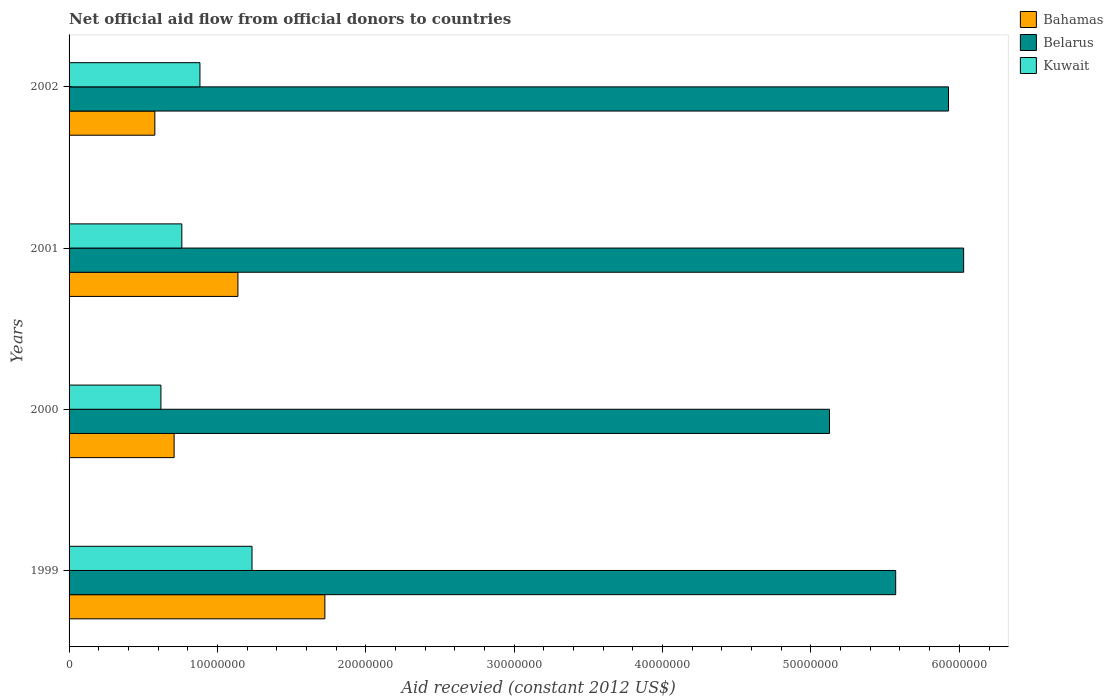Are the number of bars per tick equal to the number of legend labels?
Offer a very short reply. Yes. Are the number of bars on each tick of the Y-axis equal?
Offer a very short reply. Yes. How many bars are there on the 4th tick from the top?
Offer a terse response. 3. How many bars are there on the 3rd tick from the bottom?
Provide a succinct answer. 3. What is the label of the 2nd group of bars from the top?
Ensure brevity in your answer.  2001. What is the total aid received in Kuwait in 2001?
Provide a succinct answer. 7.60e+06. Across all years, what is the maximum total aid received in Bahamas?
Your response must be concise. 1.72e+07. Across all years, what is the minimum total aid received in Kuwait?
Offer a very short reply. 6.19e+06. In which year was the total aid received in Bahamas minimum?
Provide a short and direct response. 2002. What is the total total aid received in Bahamas in the graph?
Keep it short and to the point. 4.15e+07. What is the difference between the total aid received in Belarus in 1999 and that in 2001?
Your response must be concise. -4.58e+06. What is the difference between the total aid received in Bahamas in 2000 and the total aid received in Belarus in 2001?
Ensure brevity in your answer.  -5.32e+07. What is the average total aid received in Belarus per year?
Provide a short and direct response. 5.66e+07. In the year 2002, what is the difference between the total aid received in Bahamas and total aid received in Belarus?
Offer a terse response. -5.35e+07. What is the ratio of the total aid received in Bahamas in 2001 to that in 2002?
Make the answer very short. 1.97. Is the total aid received in Kuwait in 2001 less than that in 2002?
Offer a very short reply. Yes. What is the difference between the highest and the second highest total aid received in Kuwait?
Offer a very short reply. 3.51e+06. What is the difference between the highest and the lowest total aid received in Bahamas?
Provide a short and direct response. 1.15e+07. In how many years, is the total aid received in Kuwait greater than the average total aid received in Kuwait taken over all years?
Your answer should be compact. 2. What does the 3rd bar from the top in 1999 represents?
Make the answer very short. Bahamas. What does the 3rd bar from the bottom in 2001 represents?
Keep it short and to the point. Kuwait. Is it the case that in every year, the sum of the total aid received in Belarus and total aid received in Bahamas is greater than the total aid received in Kuwait?
Make the answer very short. Yes. How many bars are there?
Give a very brief answer. 12. What is the difference between two consecutive major ticks on the X-axis?
Your answer should be very brief. 1.00e+07. Does the graph contain any zero values?
Your response must be concise. No. Does the graph contain grids?
Ensure brevity in your answer.  No. Where does the legend appear in the graph?
Make the answer very short. Top right. What is the title of the graph?
Offer a terse response. Net official aid flow from official donors to countries. What is the label or title of the X-axis?
Your answer should be compact. Aid recevied (constant 2012 US$). What is the Aid recevied (constant 2012 US$) in Bahamas in 1999?
Your answer should be compact. 1.72e+07. What is the Aid recevied (constant 2012 US$) of Belarus in 1999?
Give a very brief answer. 5.57e+07. What is the Aid recevied (constant 2012 US$) of Kuwait in 1999?
Ensure brevity in your answer.  1.23e+07. What is the Aid recevied (constant 2012 US$) of Bahamas in 2000?
Give a very brief answer. 7.08e+06. What is the Aid recevied (constant 2012 US$) of Belarus in 2000?
Offer a very short reply. 5.12e+07. What is the Aid recevied (constant 2012 US$) in Kuwait in 2000?
Your answer should be compact. 6.19e+06. What is the Aid recevied (constant 2012 US$) in Bahamas in 2001?
Ensure brevity in your answer.  1.14e+07. What is the Aid recevied (constant 2012 US$) of Belarus in 2001?
Your response must be concise. 6.03e+07. What is the Aid recevied (constant 2012 US$) of Kuwait in 2001?
Ensure brevity in your answer.  7.60e+06. What is the Aid recevied (constant 2012 US$) of Bahamas in 2002?
Offer a very short reply. 5.78e+06. What is the Aid recevied (constant 2012 US$) in Belarus in 2002?
Provide a succinct answer. 5.93e+07. What is the Aid recevied (constant 2012 US$) in Kuwait in 2002?
Make the answer very short. 8.82e+06. Across all years, what is the maximum Aid recevied (constant 2012 US$) of Bahamas?
Give a very brief answer. 1.72e+07. Across all years, what is the maximum Aid recevied (constant 2012 US$) of Belarus?
Provide a short and direct response. 6.03e+07. Across all years, what is the maximum Aid recevied (constant 2012 US$) in Kuwait?
Offer a terse response. 1.23e+07. Across all years, what is the minimum Aid recevied (constant 2012 US$) in Bahamas?
Your response must be concise. 5.78e+06. Across all years, what is the minimum Aid recevied (constant 2012 US$) in Belarus?
Keep it short and to the point. 5.12e+07. Across all years, what is the minimum Aid recevied (constant 2012 US$) of Kuwait?
Your answer should be compact. 6.19e+06. What is the total Aid recevied (constant 2012 US$) of Bahamas in the graph?
Your response must be concise. 4.15e+07. What is the total Aid recevied (constant 2012 US$) in Belarus in the graph?
Offer a very short reply. 2.27e+08. What is the total Aid recevied (constant 2012 US$) in Kuwait in the graph?
Make the answer very short. 3.49e+07. What is the difference between the Aid recevied (constant 2012 US$) in Bahamas in 1999 and that in 2000?
Your answer should be compact. 1.02e+07. What is the difference between the Aid recevied (constant 2012 US$) in Belarus in 1999 and that in 2000?
Provide a succinct answer. 4.46e+06. What is the difference between the Aid recevied (constant 2012 US$) in Kuwait in 1999 and that in 2000?
Give a very brief answer. 6.14e+06. What is the difference between the Aid recevied (constant 2012 US$) of Bahamas in 1999 and that in 2001?
Keep it short and to the point. 5.86e+06. What is the difference between the Aid recevied (constant 2012 US$) in Belarus in 1999 and that in 2001?
Provide a short and direct response. -4.58e+06. What is the difference between the Aid recevied (constant 2012 US$) of Kuwait in 1999 and that in 2001?
Offer a terse response. 4.73e+06. What is the difference between the Aid recevied (constant 2012 US$) of Bahamas in 1999 and that in 2002?
Keep it short and to the point. 1.15e+07. What is the difference between the Aid recevied (constant 2012 US$) in Belarus in 1999 and that in 2002?
Provide a short and direct response. -3.56e+06. What is the difference between the Aid recevied (constant 2012 US$) in Kuwait in 1999 and that in 2002?
Keep it short and to the point. 3.51e+06. What is the difference between the Aid recevied (constant 2012 US$) in Bahamas in 2000 and that in 2001?
Provide a short and direct response. -4.30e+06. What is the difference between the Aid recevied (constant 2012 US$) in Belarus in 2000 and that in 2001?
Give a very brief answer. -9.04e+06. What is the difference between the Aid recevied (constant 2012 US$) in Kuwait in 2000 and that in 2001?
Offer a terse response. -1.41e+06. What is the difference between the Aid recevied (constant 2012 US$) in Bahamas in 2000 and that in 2002?
Offer a terse response. 1.30e+06. What is the difference between the Aid recevied (constant 2012 US$) in Belarus in 2000 and that in 2002?
Make the answer very short. -8.02e+06. What is the difference between the Aid recevied (constant 2012 US$) of Kuwait in 2000 and that in 2002?
Provide a succinct answer. -2.63e+06. What is the difference between the Aid recevied (constant 2012 US$) of Bahamas in 2001 and that in 2002?
Your answer should be compact. 5.60e+06. What is the difference between the Aid recevied (constant 2012 US$) of Belarus in 2001 and that in 2002?
Make the answer very short. 1.02e+06. What is the difference between the Aid recevied (constant 2012 US$) in Kuwait in 2001 and that in 2002?
Make the answer very short. -1.22e+06. What is the difference between the Aid recevied (constant 2012 US$) of Bahamas in 1999 and the Aid recevied (constant 2012 US$) of Belarus in 2000?
Provide a succinct answer. -3.40e+07. What is the difference between the Aid recevied (constant 2012 US$) of Bahamas in 1999 and the Aid recevied (constant 2012 US$) of Kuwait in 2000?
Provide a succinct answer. 1.10e+07. What is the difference between the Aid recevied (constant 2012 US$) of Belarus in 1999 and the Aid recevied (constant 2012 US$) of Kuwait in 2000?
Your answer should be very brief. 4.95e+07. What is the difference between the Aid recevied (constant 2012 US$) of Bahamas in 1999 and the Aid recevied (constant 2012 US$) of Belarus in 2001?
Keep it short and to the point. -4.30e+07. What is the difference between the Aid recevied (constant 2012 US$) of Bahamas in 1999 and the Aid recevied (constant 2012 US$) of Kuwait in 2001?
Make the answer very short. 9.64e+06. What is the difference between the Aid recevied (constant 2012 US$) of Belarus in 1999 and the Aid recevied (constant 2012 US$) of Kuwait in 2001?
Give a very brief answer. 4.81e+07. What is the difference between the Aid recevied (constant 2012 US$) of Bahamas in 1999 and the Aid recevied (constant 2012 US$) of Belarus in 2002?
Ensure brevity in your answer.  -4.20e+07. What is the difference between the Aid recevied (constant 2012 US$) in Bahamas in 1999 and the Aid recevied (constant 2012 US$) in Kuwait in 2002?
Make the answer very short. 8.42e+06. What is the difference between the Aid recevied (constant 2012 US$) in Belarus in 1999 and the Aid recevied (constant 2012 US$) in Kuwait in 2002?
Your answer should be compact. 4.69e+07. What is the difference between the Aid recevied (constant 2012 US$) in Bahamas in 2000 and the Aid recevied (constant 2012 US$) in Belarus in 2001?
Make the answer very short. -5.32e+07. What is the difference between the Aid recevied (constant 2012 US$) of Bahamas in 2000 and the Aid recevied (constant 2012 US$) of Kuwait in 2001?
Ensure brevity in your answer.  -5.20e+05. What is the difference between the Aid recevied (constant 2012 US$) of Belarus in 2000 and the Aid recevied (constant 2012 US$) of Kuwait in 2001?
Offer a terse response. 4.36e+07. What is the difference between the Aid recevied (constant 2012 US$) of Bahamas in 2000 and the Aid recevied (constant 2012 US$) of Belarus in 2002?
Make the answer very short. -5.22e+07. What is the difference between the Aid recevied (constant 2012 US$) in Bahamas in 2000 and the Aid recevied (constant 2012 US$) in Kuwait in 2002?
Your answer should be very brief. -1.74e+06. What is the difference between the Aid recevied (constant 2012 US$) of Belarus in 2000 and the Aid recevied (constant 2012 US$) of Kuwait in 2002?
Your answer should be very brief. 4.24e+07. What is the difference between the Aid recevied (constant 2012 US$) of Bahamas in 2001 and the Aid recevied (constant 2012 US$) of Belarus in 2002?
Your answer should be very brief. -4.79e+07. What is the difference between the Aid recevied (constant 2012 US$) of Bahamas in 2001 and the Aid recevied (constant 2012 US$) of Kuwait in 2002?
Your answer should be very brief. 2.56e+06. What is the difference between the Aid recevied (constant 2012 US$) in Belarus in 2001 and the Aid recevied (constant 2012 US$) in Kuwait in 2002?
Offer a very short reply. 5.15e+07. What is the average Aid recevied (constant 2012 US$) of Bahamas per year?
Offer a terse response. 1.04e+07. What is the average Aid recevied (constant 2012 US$) of Belarus per year?
Your answer should be very brief. 5.66e+07. What is the average Aid recevied (constant 2012 US$) of Kuwait per year?
Give a very brief answer. 8.74e+06. In the year 1999, what is the difference between the Aid recevied (constant 2012 US$) of Bahamas and Aid recevied (constant 2012 US$) of Belarus?
Keep it short and to the point. -3.85e+07. In the year 1999, what is the difference between the Aid recevied (constant 2012 US$) in Bahamas and Aid recevied (constant 2012 US$) in Kuwait?
Offer a terse response. 4.91e+06. In the year 1999, what is the difference between the Aid recevied (constant 2012 US$) of Belarus and Aid recevied (constant 2012 US$) of Kuwait?
Your response must be concise. 4.34e+07. In the year 2000, what is the difference between the Aid recevied (constant 2012 US$) of Bahamas and Aid recevied (constant 2012 US$) of Belarus?
Your answer should be very brief. -4.42e+07. In the year 2000, what is the difference between the Aid recevied (constant 2012 US$) of Bahamas and Aid recevied (constant 2012 US$) of Kuwait?
Offer a terse response. 8.90e+05. In the year 2000, what is the difference between the Aid recevied (constant 2012 US$) of Belarus and Aid recevied (constant 2012 US$) of Kuwait?
Keep it short and to the point. 4.51e+07. In the year 2001, what is the difference between the Aid recevied (constant 2012 US$) in Bahamas and Aid recevied (constant 2012 US$) in Belarus?
Offer a terse response. -4.89e+07. In the year 2001, what is the difference between the Aid recevied (constant 2012 US$) of Bahamas and Aid recevied (constant 2012 US$) of Kuwait?
Your answer should be very brief. 3.78e+06. In the year 2001, what is the difference between the Aid recevied (constant 2012 US$) of Belarus and Aid recevied (constant 2012 US$) of Kuwait?
Give a very brief answer. 5.27e+07. In the year 2002, what is the difference between the Aid recevied (constant 2012 US$) of Bahamas and Aid recevied (constant 2012 US$) of Belarus?
Make the answer very short. -5.35e+07. In the year 2002, what is the difference between the Aid recevied (constant 2012 US$) of Bahamas and Aid recevied (constant 2012 US$) of Kuwait?
Your answer should be very brief. -3.04e+06. In the year 2002, what is the difference between the Aid recevied (constant 2012 US$) of Belarus and Aid recevied (constant 2012 US$) of Kuwait?
Ensure brevity in your answer.  5.04e+07. What is the ratio of the Aid recevied (constant 2012 US$) in Bahamas in 1999 to that in 2000?
Keep it short and to the point. 2.44. What is the ratio of the Aid recevied (constant 2012 US$) of Belarus in 1999 to that in 2000?
Offer a very short reply. 1.09. What is the ratio of the Aid recevied (constant 2012 US$) of Kuwait in 1999 to that in 2000?
Offer a terse response. 1.99. What is the ratio of the Aid recevied (constant 2012 US$) of Bahamas in 1999 to that in 2001?
Provide a succinct answer. 1.51. What is the ratio of the Aid recevied (constant 2012 US$) in Belarus in 1999 to that in 2001?
Provide a short and direct response. 0.92. What is the ratio of the Aid recevied (constant 2012 US$) of Kuwait in 1999 to that in 2001?
Ensure brevity in your answer.  1.62. What is the ratio of the Aid recevied (constant 2012 US$) in Bahamas in 1999 to that in 2002?
Ensure brevity in your answer.  2.98. What is the ratio of the Aid recevied (constant 2012 US$) of Belarus in 1999 to that in 2002?
Give a very brief answer. 0.94. What is the ratio of the Aid recevied (constant 2012 US$) in Kuwait in 1999 to that in 2002?
Your answer should be very brief. 1.4. What is the ratio of the Aid recevied (constant 2012 US$) of Bahamas in 2000 to that in 2001?
Make the answer very short. 0.62. What is the ratio of the Aid recevied (constant 2012 US$) of Belarus in 2000 to that in 2001?
Your answer should be compact. 0.85. What is the ratio of the Aid recevied (constant 2012 US$) of Kuwait in 2000 to that in 2001?
Offer a very short reply. 0.81. What is the ratio of the Aid recevied (constant 2012 US$) of Bahamas in 2000 to that in 2002?
Offer a very short reply. 1.22. What is the ratio of the Aid recevied (constant 2012 US$) of Belarus in 2000 to that in 2002?
Ensure brevity in your answer.  0.86. What is the ratio of the Aid recevied (constant 2012 US$) in Kuwait in 2000 to that in 2002?
Make the answer very short. 0.7. What is the ratio of the Aid recevied (constant 2012 US$) of Bahamas in 2001 to that in 2002?
Your answer should be compact. 1.97. What is the ratio of the Aid recevied (constant 2012 US$) in Belarus in 2001 to that in 2002?
Ensure brevity in your answer.  1.02. What is the ratio of the Aid recevied (constant 2012 US$) of Kuwait in 2001 to that in 2002?
Keep it short and to the point. 0.86. What is the difference between the highest and the second highest Aid recevied (constant 2012 US$) of Bahamas?
Keep it short and to the point. 5.86e+06. What is the difference between the highest and the second highest Aid recevied (constant 2012 US$) in Belarus?
Give a very brief answer. 1.02e+06. What is the difference between the highest and the second highest Aid recevied (constant 2012 US$) in Kuwait?
Your answer should be compact. 3.51e+06. What is the difference between the highest and the lowest Aid recevied (constant 2012 US$) in Bahamas?
Keep it short and to the point. 1.15e+07. What is the difference between the highest and the lowest Aid recevied (constant 2012 US$) in Belarus?
Ensure brevity in your answer.  9.04e+06. What is the difference between the highest and the lowest Aid recevied (constant 2012 US$) of Kuwait?
Give a very brief answer. 6.14e+06. 